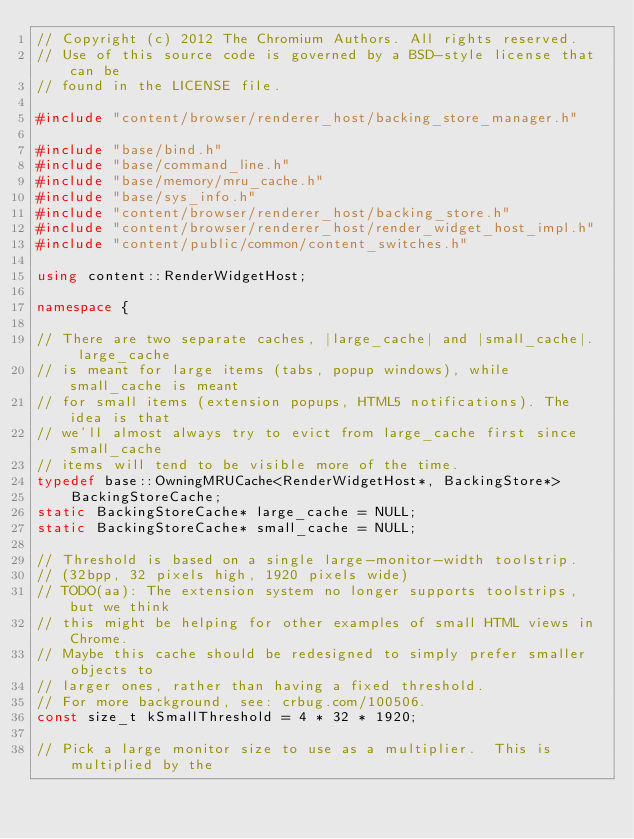Convert code to text. <code><loc_0><loc_0><loc_500><loc_500><_C++_>// Copyright (c) 2012 The Chromium Authors. All rights reserved.
// Use of this source code is governed by a BSD-style license that can be
// found in the LICENSE file.

#include "content/browser/renderer_host/backing_store_manager.h"

#include "base/bind.h"
#include "base/command_line.h"
#include "base/memory/mru_cache.h"
#include "base/sys_info.h"
#include "content/browser/renderer_host/backing_store.h"
#include "content/browser/renderer_host/render_widget_host_impl.h"
#include "content/public/common/content_switches.h"

using content::RenderWidgetHost;

namespace {

// There are two separate caches, |large_cache| and |small_cache|.  large_cache
// is meant for large items (tabs, popup windows), while small_cache is meant
// for small items (extension popups, HTML5 notifications). The idea is that
// we'll almost always try to evict from large_cache first since small_cache
// items will tend to be visible more of the time.
typedef base::OwningMRUCache<RenderWidgetHost*, BackingStore*>
    BackingStoreCache;
static BackingStoreCache* large_cache = NULL;
static BackingStoreCache* small_cache = NULL;

// Threshold is based on a single large-monitor-width toolstrip.
// (32bpp, 32 pixels high, 1920 pixels wide)
// TODO(aa): The extension system no longer supports toolstrips, but we think
// this might be helping for other examples of small HTML views in Chrome.
// Maybe this cache should be redesigned to simply prefer smaller objects to
// larger ones, rather than having a fixed threshold.
// For more background, see: crbug.com/100506.
const size_t kSmallThreshold = 4 * 32 * 1920;

// Pick a large monitor size to use as a multiplier.  This is multiplied by the</code> 